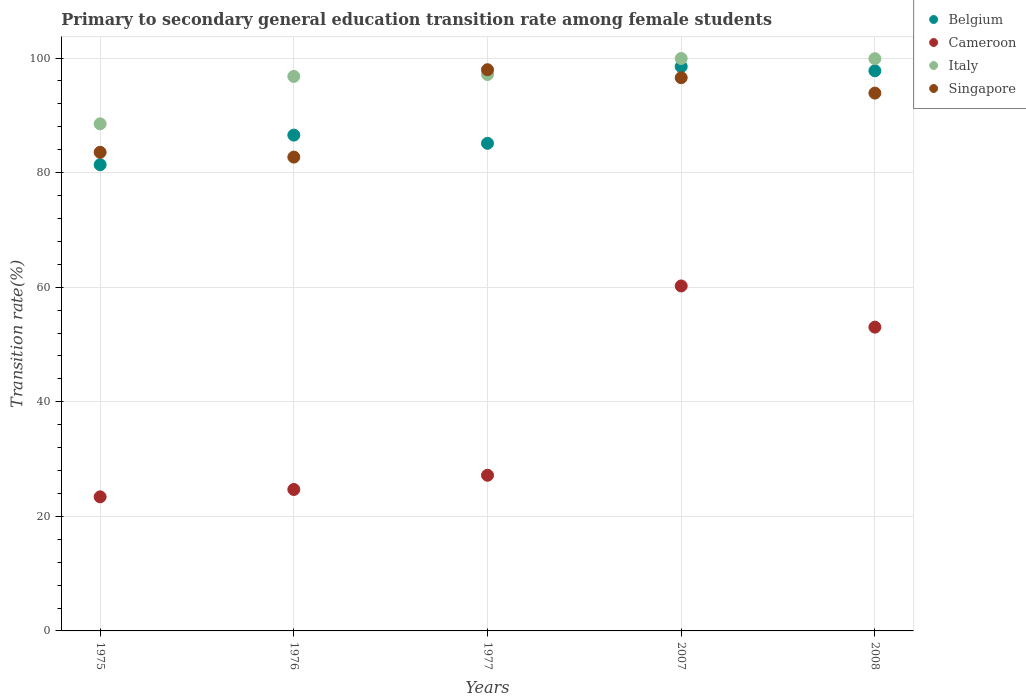How many different coloured dotlines are there?
Your answer should be very brief. 4. What is the transition rate in Belgium in 1977?
Give a very brief answer. 85.11. Across all years, what is the maximum transition rate in Cameroon?
Make the answer very short. 60.22. Across all years, what is the minimum transition rate in Singapore?
Ensure brevity in your answer.  82.71. In which year was the transition rate in Singapore maximum?
Provide a short and direct response. 1977. In which year was the transition rate in Italy minimum?
Keep it short and to the point. 1975. What is the total transition rate in Belgium in the graph?
Ensure brevity in your answer.  449.34. What is the difference between the transition rate in Cameroon in 1975 and that in 1977?
Offer a terse response. -3.76. What is the difference between the transition rate in Cameroon in 2008 and the transition rate in Belgium in 1977?
Offer a terse response. -32.09. What is the average transition rate in Belgium per year?
Ensure brevity in your answer.  89.87. In the year 1975, what is the difference between the transition rate in Italy and transition rate in Cameroon?
Your answer should be compact. 65.11. In how many years, is the transition rate in Italy greater than 56 %?
Provide a short and direct response. 5. What is the ratio of the transition rate in Belgium in 1975 to that in 2007?
Keep it short and to the point. 0.83. Is the transition rate in Belgium in 1975 less than that in 2008?
Ensure brevity in your answer.  Yes. Is the difference between the transition rate in Italy in 1975 and 1977 greater than the difference between the transition rate in Cameroon in 1975 and 1977?
Offer a very short reply. No. What is the difference between the highest and the second highest transition rate in Italy?
Make the answer very short. 0.04. What is the difference between the highest and the lowest transition rate in Singapore?
Provide a short and direct response. 15.25. In how many years, is the transition rate in Cameroon greater than the average transition rate in Cameroon taken over all years?
Your response must be concise. 2. Is the sum of the transition rate in Belgium in 1976 and 1977 greater than the maximum transition rate in Cameroon across all years?
Your answer should be compact. Yes. How many dotlines are there?
Give a very brief answer. 4. What is the difference between two consecutive major ticks on the Y-axis?
Provide a short and direct response. 20. Does the graph contain any zero values?
Offer a terse response. No. Where does the legend appear in the graph?
Provide a short and direct response. Top right. How are the legend labels stacked?
Your answer should be compact. Vertical. What is the title of the graph?
Your response must be concise. Primary to secondary general education transition rate among female students. What is the label or title of the X-axis?
Make the answer very short. Years. What is the label or title of the Y-axis?
Make the answer very short. Transition rate(%). What is the Transition rate(%) in Belgium in 1975?
Offer a very short reply. 81.38. What is the Transition rate(%) of Cameroon in 1975?
Ensure brevity in your answer.  23.41. What is the Transition rate(%) of Italy in 1975?
Make the answer very short. 88.52. What is the Transition rate(%) in Singapore in 1975?
Ensure brevity in your answer.  83.55. What is the Transition rate(%) of Belgium in 1976?
Give a very brief answer. 86.55. What is the Transition rate(%) in Cameroon in 1976?
Your response must be concise. 24.69. What is the Transition rate(%) of Italy in 1976?
Ensure brevity in your answer.  96.79. What is the Transition rate(%) in Singapore in 1976?
Provide a short and direct response. 82.71. What is the Transition rate(%) in Belgium in 1977?
Provide a succinct answer. 85.11. What is the Transition rate(%) in Cameroon in 1977?
Your answer should be compact. 27.17. What is the Transition rate(%) in Italy in 1977?
Your answer should be very brief. 97.13. What is the Transition rate(%) in Singapore in 1977?
Offer a terse response. 97.96. What is the Transition rate(%) in Belgium in 2007?
Your answer should be compact. 98.52. What is the Transition rate(%) in Cameroon in 2007?
Ensure brevity in your answer.  60.22. What is the Transition rate(%) in Italy in 2007?
Your response must be concise. 99.92. What is the Transition rate(%) of Singapore in 2007?
Ensure brevity in your answer.  96.57. What is the Transition rate(%) of Belgium in 2008?
Ensure brevity in your answer.  97.78. What is the Transition rate(%) of Cameroon in 2008?
Your answer should be compact. 53.03. What is the Transition rate(%) of Italy in 2008?
Make the answer very short. 99.89. What is the Transition rate(%) in Singapore in 2008?
Give a very brief answer. 93.88. Across all years, what is the maximum Transition rate(%) in Belgium?
Ensure brevity in your answer.  98.52. Across all years, what is the maximum Transition rate(%) of Cameroon?
Offer a terse response. 60.22. Across all years, what is the maximum Transition rate(%) in Italy?
Offer a terse response. 99.92. Across all years, what is the maximum Transition rate(%) in Singapore?
Your response must be concise. 97.96. Across all years, what is the minimum Transition rate(%) of Belgium?
Make the answer very short. 81.38. Across all years, what is the minimum Transition rate(%) of Cameroon?
Provide a short and direct response. 23.41. Across all years, what is the minimum Transition rate(%) of Italy?
Offer a very short reply. 88.52. Across all years, what is the minimum Transition rate(%) of Singapore?
Give a very brief answer. 82.71. What is the total Transition rate(%) of Belgium in the graph?
Your answer should be very brief. 449.34. What is the total Transition rate(%) in Cameroon in the graph?
Offer a terse response. 188.51. What is the total Transition rate(%) in Italy in the graph?
Your response must be concise. 482.25. What is the total Transition rate(%) in Singapore in the graph?
Keep it short and to the point. 454.67. What is the difference between the Transition rate(%) of Belgium in 1975 and that in 1976?
Give a very brief answer. -5.17. What is the difference between the Transition rate(%) of Cameroon in 1975 and that in 1976?
Make the answer very short. -1.28. What is the difference between the Transition rate(%) of Italy in 1975 and that in 1976?
Offer a terse response. -8.27. What is the difference between the Transition rate(%) of Singapore in 1975 and that in 1976?
Ensure brevity in your answer.  0.84. What is the difference between the Transition rate(%) of Belgium in 1975 and that in 1977?
Offer a terse response. -3.73. What is the difference between the Transition rate(%) in Cameroon in 1975 and that in 1977?
Keep it short and to the point. -3.76. What is the difference between the Transition rate(%) of Italy in 1975 and that in 1977?
Your response must be concise. -8.61. What is the difference between the Transition rate(%) of Singapore in 1975 and that in 1977?
Your answer should be compact. -14.42. What is the difference between the Transition rate(%) of Belgium in 1975 and that in 2007?
Make the answer very short. -17.13. What is the difference between the Transition rate(%) in Cameroon in 1975 and that in 2007?
Provide a short and direct response. -36.81. What is the difference between the Transition rate(%) of Italy in 1975 and that in 2007?
Offer a very short reply. -11.4. What is the difference between the Transition rate(%) of Singapore in 1975 and that in 2007?
Ensure brevity in your answer.  -13.02. What is the difference between the Transition rate(%) of Belgium in 1975 and that in 2008?
Your answer should be compact. -16.39. What is the difference between the Transition rate(%) of Cameroon in 1975 and that in 2008?
Provide a short and direct response. -29.62. What is the difference between the Transition rate(%) of Italy in 1975 and that in 2008?
Make the answer very short. -11.37. What is the difference between the Transition rate(%) in Singapore in 1975 and that in 2008?
Your response must be concise. -10.33. What is the difference between the Transition rate(%) of Belgium in 1976 and that in 1977?
Your answer should be very brief. 1.44. What is the difference between the Transition rate(%) in Cameroon in 1976 and that in 1977?
Ensure brevity in your answer.  -2.48. What is the difference between the Transition rate(%) in Italy in 1976 and that in 1977?
Ensure brevity in your answer.  -0.33. What is the difference between the Transition rate(%) of Singapore in 1976 and that in 1977?
Give a very brief answer. -15.25. What is the difference between the Transition rate(%) in Belgium in 1976 and that in 2007?
Your answer should be compact. -11.97. What is the difference between the Transition rate(%) of Cameroon in 1976 and that in 2007?
Offer a terse response. -35.53. What is the difference between the Transition rate(%) in Italy in 1976 and that in 2007?
Ensure brevity in your answer.  -3.13. What is the difference between the Transition rate(%) in Singapore in 1976 and that in 2007?
Your response must be concise. -13.86. What is the difference between the Transition rate(%) of Belgium in 1976 and that in 2008?
Offer a terse response. -11.23. What is the difference between the Transition rate(%) of Cameroon in 1976 and that in 2008?
Offer a terse response. -28.34. What is the difference between the Transition rate(%) of Italy in 1976 and that in 2008?
Offer a terse response. -3.09. What is the difference between the Transition rate(%) in Singapore in 1976 and that in 2008?
Provide a succinct answer. -11.17. What is the difference between the Transition rate(%) in Belgium in 1977 and that in 2007?
Your response must be concise. -13.4. What is the difference between the Transition rate(%) in Cameroon in 1977 and that in 2007?
Offer a terse response. -33.05. What is the difference between the Transition rate(%) of Italy in 1977 and that in 2007?
Your answer should be very brief. -2.8. What is the difference between the Transition rate(%) of Singapore in 1977 and that in 2007?
Keep it short and to the point. 1.4. What is the difference between the Transition rate(%) in Belgium in 1977 and that in 2008?
Give a very brief answer. -12.66. What is the difference between the Transition rate(%) of Cameroon in 1977 and that in 2008?
Give a very brief answer. -25.85. What is the difference between the Transition rate(%) in Italy in 1977 and that in 2008?
Give a very brief answer. -2.76. What is the difference between the Transition rate(%) of Singapore in 1977 and that in 2008?
Make the answer very short. 4.08. What is the difference between the Transition rate(%) of Belgium in 2007 and that in 2008?
Offer a very short reply. 0.74. What is the difference between the Transition rate(%) in Cameroon in 2007 and that in 2008?
Your response must be concise. 7.19. What is the difference between the Transition rate(%) in Italy in 2007 and that in 2008?
Make the answer very short. 0.04. What is the difference between the Transition rate(%) of Singapore in 2007 and that in 2008?
Your answer should be very brief. 2.69. What is the difference between the Transition rate(%) in Belgium in 1975 and the Transition rate(%) in Cameroon in 1976?
Give a very brief answer. 56.69. What is the difference between the Transition rate(%) in Belgium in 1975 and the Transition rate(%) in Italy in 1976?
Provide a succinct answer. -15.41. What is the difference between the Transition rate(%) in Belgium in 1975 and the Transition rate(%) in Singapore in 1976?
Provide a succinct answer. -1.33. What is the difference between the Transition rate(%) of Cameroon in 1975 and the Transition rate(%) of Italy in 1976?
Provide a short and direct response. -73.39. What is the difference between the Transition rate(%) of Cameroon in 1975 and the Transition rate(%) of Singapore in 1976?
Make the answer very short. -59.3. What is the difference between the Transition rate(%) in Italy in 1975 and the Transition rate(%) in Singapore in 1976?
Give a very brief answer. 5.81. What is the difference between the Transition rate(%) of Belgium in 1975 and the Transition rate(%) of Cameroon in 1977?
Give a very brief answer. 54.21. What is the difference between the Transition rate(%) in Belgium in 1975 and the Transition rate(%) in Italy in 1977?
Give a very brief answer. -15.74. What is the difference between the Transition rate(%) of Belgium in 1975 and the Transition rate(%) of Singapore in 1977?
Provide a succinct answer. -16.58. What is the difference between the Transition rate(%) in Cameroon in 1975 and the Transition rate(%) in Italy in 1977?
Provide a short and direct response. -73.72. What is the difference between the Transition rate(%) of Cameroon in 1975 and the Transition rate(%) of Singapore in 1977?
Make the answer very short. -74.56. What is the difference between the Transition rate(%) of Italy in 1975 and the Transition rate(%) of Singapore in 1977?
Give a very brief answer. -9.44. What is the difference between the Transition rate(%) of Belgium in 1975 and the Transition rate(%) of Cameroon in 2007?
Keep it short and to the point. 21.16. What is the difference between the Transition rate(%) in Belgium in 1975 and the Transition rate(%) in Italy in 2007?
Provide a short and direct response. -18.54. What is the difference between the Transition rate(%) of Belgium in 1975 and the Transition rate(%) of Singapore in 2007?
Provide a short and direct response. -15.18. What is the difference between the Transition rate(%) in Cameroon in 1975 and the Transition rate(%) in Italy in 2007?
Offer a terse response. -76.52. What is the difference between the Transition rate(%) in Cameroon in 1975 and the Transition rate(%) in Singapore in 2007?
Your response must be concise. -73.16. What is the difference between the Transition rate(%) of Italy in 1975 and the Transition rate(%) of Singapore in 2007?
Provide a succinct answer. -8.05. What is the difference between the Transition rate(%) in Belgium in 1975 and the Transition rate(%) in Cameroon in 2008?
Offer a terse response. 28.36. What is the difference between the Transition rate(%) of Belgium in 1975 and the Transition rate(%) of Italy in 2008?
Provide a short and direct response. -18.5. What is the difference between the Transition rate(%) of Belgium in 1975 and the Transition rate(%) of Singapore in 2008?
Give a very brief answer. -12.5. What is the difference between the Transition rate(%) of Cameroon in 1975 and the Transition rate(%) of Italy in 2008?
Ensure brevity in your answer.  -76.48. What is the difference between the Transition rate(%) in Cameroon in 1975 and the Transition rate(%) in Singapore in 2008?
Give a very brief answer. -70.47. What is the difference between the Transition rate(%) of Italy in 1975 and the Transition rate(%) of Singapore in 2008?
Make the answer very short. -5.36. What is the difference between the Transition rate(%) in Belgium in 1976 and the Transition rate(%) in Cameroon in 1977?
Ensure brevity in your answer.  59.38. What is the difference between the Transition rate(%) of Belgium in 1976 and the Transition rate(%) of Italy in 1977?
Make the answer very short. -10.58. What is the difference between the Transition rate(%) in Belgium in 1976 and the Transition rate(%) in Singapore in 1977?
Provide a succinct answer. -11.42. What is the difference between the Transition rate(%) in Cameroon in 1976 and the Transition rate(%) in Italy in 1977?
Provide a succinct answer. -72.44. What is the difference between the Transition rate(%) in Cameroon in 1976 and the Transition rate(%) in Singapore in 1977?
Give a very brief answer. -73.27. What is the difference between the Transition rate(%) in Italy in 1976 and the Transition rate(%) in Singapore in 1977?
Give a very brief answer. -1.17. What is the difference between the Transition rate(%) of Belgium in 1976 and the Transition rate(%) of Cameroon in 2007?
Your answer should be compact. 26.33. What is the difference between the Transition rate(%) of Belgium in 1976 and the Transition rate(%) of Italy in 2007?
Offer a terse response. -13.37. What is the difference between the Transition rate(%) of Belgium in 1976 and the Transition rate(%) of Singapore in 2007?
Provide a succinct answer. -10.02. What is the difference between the Transition rate(%) in Cameroon in 1976 and the Transition rate(%) in Italy in 2007?
Give a very brief answer. -75.23. What is the difference between the Transition rate(%) of Cameroon in 1976 and the Transition rate(%) of Singapore in 2007?
Offer a terse response. -71.88. What is the difference between the Transition rate(%) in Italy in 1976 and the Transition rate(%) in Singapore in 2007?
Your answer should be very brief. 0.23. What is the difference between the Transition rate(%) of Belgium in 1976 and the Transition rate(%) of Cameroon in 2008?
Ensure brevity in your answer.  33.52. What is the difference between the Transition rate(%) of Belgium in 1976 and the Transition rate(%) of Italy in 2008?
Give a very brief answer. -13.34. What is the difference between the Transition rate(%) in Belgium in 1976 and the Transition rate(%) in Singapore in 2008?
Your answer should be compact. -7.33. What is the difference between the Transition rate(%) of Cameroon in 1976 and the Transition rate(%) of Italy in 2008?
Offer a terse response. -75.2. What is the difference between the Transition rate(%) in Cameroon in 1976 and the Transition rate(%) in Singapore in 2008?
Keep it short and to the point. -69.19. What is the difference between the Transition rate(%) of Italy in 1976 and the Transition rate(%) of Singapore in 2008?
Give a very brief answer. 2.91. What is the difference between the Transition rate(%) of Belgium in 1977 and the Transition rate(%) of Cameroon in 2007?
Provide a succinct answer. 24.89. What is the difference between the Transition rate(%) in Belgium in 1977 and the Transition rate(%) in Italy in 2007?
Offer a very short reply. -14.81. What is the difference between the Transition rate(%) of Belgium in 1977 and the Transition rate(%) of Singapore in 2007?
Make the answer very short. -11.45. What is the difference between the Transition rate(%) of Cameroon in 1977 and the Transition rate(%) of Italy in 2007?
Offer a very short reply. -72.75. What is the difference between the Transition rate(%) of Cameroon in 1977 and the Transition rate(%) of Singapore in 2007?
Your answer should be compact. -69.4. What is the difference between the Transition rate(%) in Italy in 1977 and the Transition rate(%) in Singapore in 2007?
Your answer should be very brief. 0.56. What is the difference between the Transition rate(%) of Belgium in 1977 and the Transition rate(%) of Cameroon in 2008?
Ensure brevity in your answer.  32.09. What is the difference between the Transition rate(%) of Belgium in 1977 and the Transition rate(%) of Italy in 2008?
Give a very brief answer. -14.77. What is the difference between the Transition rate(%) in Belgium in 1977 and the Transition rate(%) in Singapore in 2008?
Make the answer very short. -8.77. What is the difference between the Transition rate(%) in Cameroon in 1977 and the Transition rate(%) in Italy in 2008?
Your response must be concise. -72.72. What is the difference between the Transition rate(%) of Cameroon in 1977 and the Transition rate(%) of Singapore in 2008?
Provide a succinct answer. -66.71. What is the difference between the Transition rate(%) in Italy in 1977 and the Transition rate(%) in Singapore in 2008?
Your answer should be very brief. 3.24. What is the difference between the Transition rate(%) in Belgium in 2007 and the Transition rate(%) in Cameroon in 2008?
Your answer should be compact. 45.49. What is the difference between the Transition rate(%) in Belgium in 2007 and the Transition rate(%) in Italy in 2008?
Provide a succinct answer. -1.37. What is the difference between the Transition rate(%) of Belgium in 2007 and the Transition rate(%) of Singapore in 2008?
Give a very brief answer. 4.63. What is the difference between the Transition rate(%) in Cameroon in 2007 and the Transition rate(%) in Italy in 2008?
Your answer should be very brief. -39.67. What is the difference between the Transition rate(%) of Cameroon in 2007 and the Transition rate(%) of Singapore in 2008?
Keep it short and to the point. -33.66. What is the difference between the Transition rate(%) in Italy in 2007 and the Transition rate(%) in Singapore in 2008?
Your answer should be very brief. 6.04. What is the average Transition rate(%) in Belgium per year?
Offer a very short reply. 89.87. What is the average Transition rate(%) of Cameroon per year?
Your answer should be very brief. 37.7. What is the average Transition rate(%) in Italy per year?
Make the answer very short. 96.45. What is the average Transition rate(%) of Singapore per year?
Keep it short and to the point. 90.93. In the year 1975, what is the difference between the Transition rate(%) in Belgium and Transition rate(%) in Cameroon?
Ensure brevity in your answer.  57.98. In the year 1975, what is the difference between the Transition rate(%) of Belgium and Transition rate(%) of Italy?
Offer a terse response. -7.14. In the year 1975, what is the difference between the Transition rate(%) of Belgium and Transition rate(%) of Singapore?
Offer a terse response. -2.16. In the year 1975, what is the difference between the Transition rate(%) in Cameroon and Transition rate(%) in Italy?
Your response must be concise. -65.11. In the year 1975, what is the difference between the Transition rate(%) of Cameroon and Transition rate(%) of Singapore?
Offer a terse response. -60.14. In the year 1975, what is the difference between the Transition rate(%) of Italy and Transition rate(%) of Singapore?
Make the answer very short. 4.97. In the year 1976, what is the difference between the Transition rate(%) in Belgium and Transition rate(%) in Cameroon?
Make the answer very short. 61.86. In the year 1976, what is the difference between the Transition rate(%) in Belgium and Transition rate(%) in Italy?
Your response must be concise. -10.24. In the year 1976, what is the difference between the Transition rate(%) of Belgium and Transition rate(%) of Singapore?
Offer a very short reply. 3.84. In the year 1976, what is the difference between the Transition rate(%) in Cameroon and Transition rate(%) in Italy?
Your response must be concise. -72.1. In the year 1976, what is the difference between the Transition rate(%) of Cameroon and Transition rate(%) of Singapore?
Give a very brief answer. -58.02. In the year 1976, what is the difference between the Transition rate(%) in Italy and Transition rate(%) in Singapore?
Provide a short and direct response. 14.08. In the year 1977, what is the difference between the Transition rate(%) in Belgium and Transition rate(%) in Cameroon?
Keep it short and to the point. 57.94. In the year 1977, what is the difference between the Transition rate(%) in Belgium and Transition rate(%) in Italy?
Make the answer very short. -12.01. In the year 1977, what is the difference between the Transition rate(%) of Belgium and Transition rate(%) of Singapore?
Your response must be concise. -12.85. In the year 1977, what is the difference between the Transition rate(%) in Cameroon and Transition rate(%) in Italy?
Your response must be concise. -69.95. In the year 1977, what is the difference between the Transition rate(%) in Cameroon and Transition rate(%) in Singapore?
Make the answer very short. -70.79. In the year 1977, what is the difference between the Transition rate(%) of Italy and Transition rate(%) of Singapore?
Provide a short and direct response. -0.84. In the year 2007, what is the difference between the Transition rate(%) in Belgium and Transition rate(%) in Cameroon?
Provide a succinct answer. 38.3. In the year 2007, what is the difference between the Transition rate(%) of Belgium and Transition rate(%) of Italy?
Provide a short and direct response. -1.41. In the year 2007, what is the difference between the Transition rate(%) of Belgium and Transition rate(%) of Singapore?
Provide a succinct answer. 1.95. In the year 2007, what is the difference between the Transition rate(%) in Cameroon and Transition rate(%) in Italy?
Provide a succinct answer. -39.7. In the year 2007, what is the difference between the Transition rate(%) of Cameroon and Transition rate(%) of Singapore?
Your answer should be compact. -36.35. In the year 2007, what is the difference between the Transition rate(%) of Italy and Transition rate(%) of Singapore?
Give a very brief answer. 3.36. In the year 2008, what is the difference between the Transition rate(%) in Belgium and Transition rate(%) in Cameroon?
Provide a succinct answer. 44.75. In the year 2008, what is the difference between the Transition rate(%) in Belgium and Transition rate(%) in Italy?
Your answer should be very brief. -2.11. In the year 2008, what is the difference between the Transition rate(%) in Belgium and Transition rate(%) in Singapore?
Give a very brief answer. 3.9. In the year 2008, what is the difference between the Transition rate(%) of Cameroon and Transition rate(%) of Italy?
Ensure brevity in your answer.  -46.86. In the year 2008, what is the difference between the Transition rate(%) in Cameroon and Transition rate(%) in Singapore?
Your response must be concise. -40.86. In the year 2008, what is the difference between the Transition rate(%) in Italy and Transition rate(%) in Singapore?
Your answer should be very brief. 6. What is the ratio of the Transition rate(%) of Belgium in 1975 to that in 1976?
Keep it short and to the point. 0.94. What is the ratio of the Transition rate(%) in Cameroon in 1975 to that in 1976?
Provide a succinct answer. 0.95. What is the ratio of the Transition rate(%) of Italy in 1975 to that in 1976?
Your answer should be very brief. 0.91. What is the ratio of the Transition rate(%) of Belgium in 1975 to that in 1977?
Offer a very short reply. 0.96. What is the ratio of the Transition rate(%) of Cameroon in 1975 to that in 1977?
Provide a short and direct response. 0.86. What is the ratio of the Transition rate(%) of Italy in 1975 to that in 1977?
Offer a very short reply. 0.91. What is the ratio of the Transition rate(%) of Singapore in 1975 to that in 1977?
Keep it short and to the point. 0.85. What is the ratio of the Transition rate(%) in Belgium in 1975 to that in 2007?
Offer a very short reply. 0.83. What is the ratio of the Transition rate(%) in Cameroon in 1975 to that in 2007?
Your answer should be compact. 0.39. What is the ratio of the Transition rate(%) of Italy in 1975 to that in 2007?
Offer a very short reply. 0.89. What is the ratio of the Transition rate(%) in Singapore in 1975 to that in 2007?
Offer a very short reply. 0.87. What is the ratio of the Transition rate(%) in Belgium in 1975 to that in 2008?
Provide a succinct answer. 0.83. What is the ratio of the Transition rate(%) in Cameroon in 1975 to that in 2008?
Give a very brief answer. 0.44. What is the ratio of the Transition rate(%) of Italy in 1975 to that in 2008?
Offer a very short reply. 0.89. What is the ratio of the Transition rate(%) in Singapore in 1975 to that in 2008?
Give a very brief answer. 0.89. What is the ratio of the Transition rate(%) in Belgium in 1976 to that in 1977?
Make the answer very short. 1.02. What is the ratio of the Transition rate(%) in Cameroon in 1976 to that in 1977?
Your answer should be compact. 0.91. What is the ratio of the Transition rate(%) in Italy in 1976 to that in 1977?
Give a very brief answer. 1. What is the ratio of the Transition rate(%) in Singapore in 1976 to that in 1977?
Offer a very short reply. 0.84. What is the ratio of the Transition rate(%) in Belgium in 1976 to that in 2007?
Offer a terse response. 0.88. What is the ratio of the Transition rate(%) in Cameroon in 1976 to that in 2007?
Provide a short and direct response. 0.41. What is the ratio of the Transition rate(%) in Italy in 1976 to that in 2007?
Keep it short and to the point. 0.97. What is the ratio of the Transition rate(%) in Singapore in 1976 to that in 2007?
Offer a very short reply. 0.86. What is the ratio of the Transition rate(%) of Belgium in 1976 to that in 2008?
Offer a very short reply. 0.89. What is the ratio of the Transition rate(%) in Cameroon in 1976 to that in 2008?
Ensure brevity in your answer.  0.47. What is the ratio of the Transition rate(%) in Singapore in 1976 to that in 2008?
Give a very brief answer. 0.88. What is the ratio of the Transition rate(%) of Belgium in 1977 to that in 2007?
Keep it short and to the point. 0.86. What is the ratio of the Transition rate(%) of Cameroon in 1977 to that in 2007?
Keep it short and to the point. 0.45. What is the ratio of the Transition rate(%) in Singapore in 1977 to that in 2007?
Keep it short and to the point. 1.01. What is the ratio of the Transition rate(%) in Belgium in 1977 to that in 2008?
Your response must be concise. 0.87. What is the ratio of the Transition rate(%) in Cameroon in 1977 to that in 2008?
Provide a short and direct response. 0.51. What is the ratio of the Transition rate(%) of Italy in 1977 to that in 2008?
Make the answer very short. 0.97. What is the ratio of the Transition rate(%) of Singapore in 1977 to that in 2008?
Your answer should be very brief. 1.04. What is the ratio of the Transition rate(%) in Belgium in 2007 to that in 2008?
Provide a short and direct response. 1.01. What is the ratio of the Transition rate(%) in Cameroon in 2007 to that in 2008?
Make the answer very short. 1.14. What is the ratio of the Transition rate(%) of Italy in 2007 to that in 2008?
Make the answer very short. 1. What is the ratio of the Transition rate(%) in Singapore in 2007 to that in 2008?
Provide a succinct answer. 1.03. What is the difference between the highest and the second highest Transition rate(%) in Belgium?
Keep it short and to the point. 0.74. What is the difference between the highest and the second highest Transition rate(%) of Cameroon?
Make the answer very short. 7.19. What is the difference between the highest and the second highest Transition rate(%) of Italy?
Ensure brevity in your answer.  0.04. What is the difference between the highest and the second highest Transition rate(%) of Singapore?
Give a very brief answer. 1.4. What is the difference between the highest and the lowest Transition rate(%) in Belgium?
Your answer should be very brief. 17.13. What is the difference between the highest and the lowest Transition rate(%) in Cameroon?
Keep it short and to the point. 36.81. What is the difference between the highest and the lowest Transition rate(%) in Italy?
Your answer should be very brief. 11.4. What is the difference between the highest and the lowest Transition rate(%) in Singapore?
Keep it short and to the point. 15.25. 